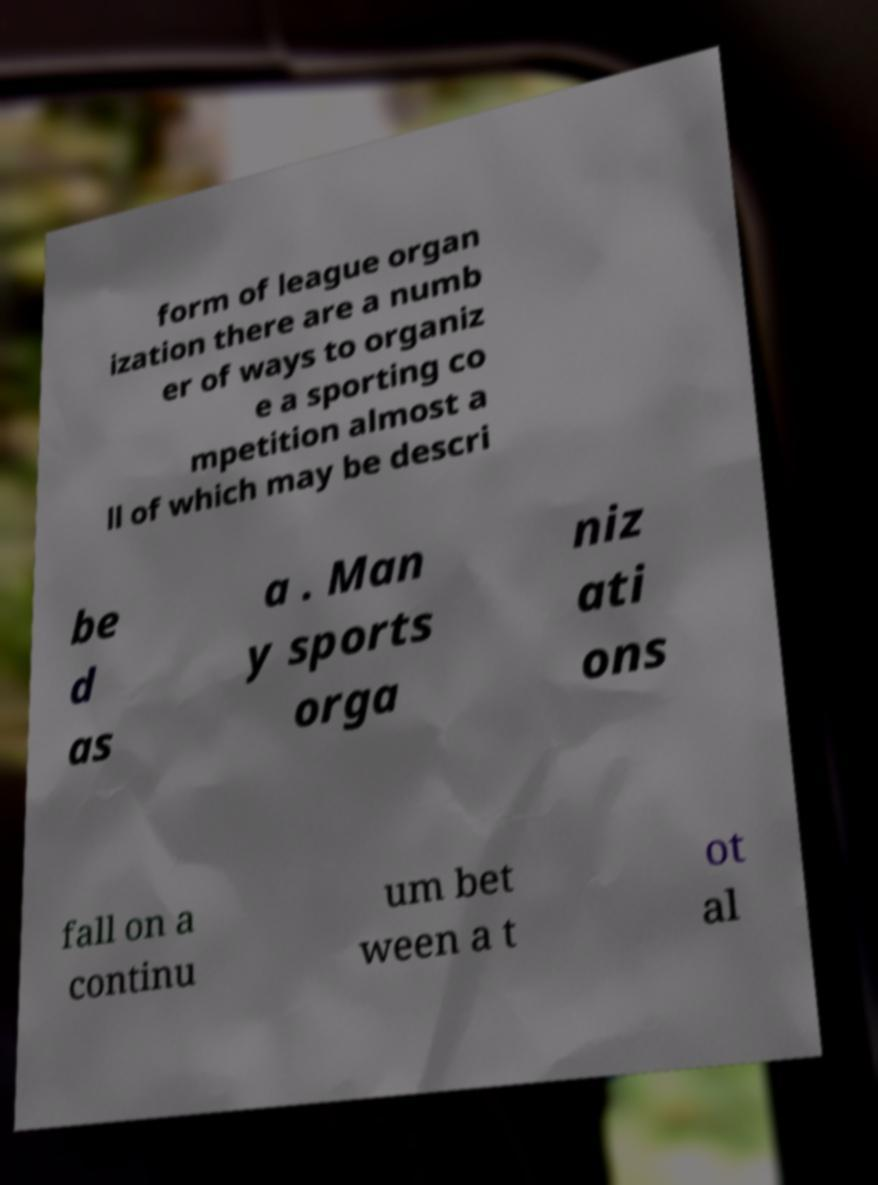Please read and relay the text visible in this image. What does it say? form of league organ ization there are a numb er of ways to organiz e a sporting co mpetition almost a ll of which may be descri be d as a . Man y sports orga niz ati ons fall on a continu um bet ween a t ot al 